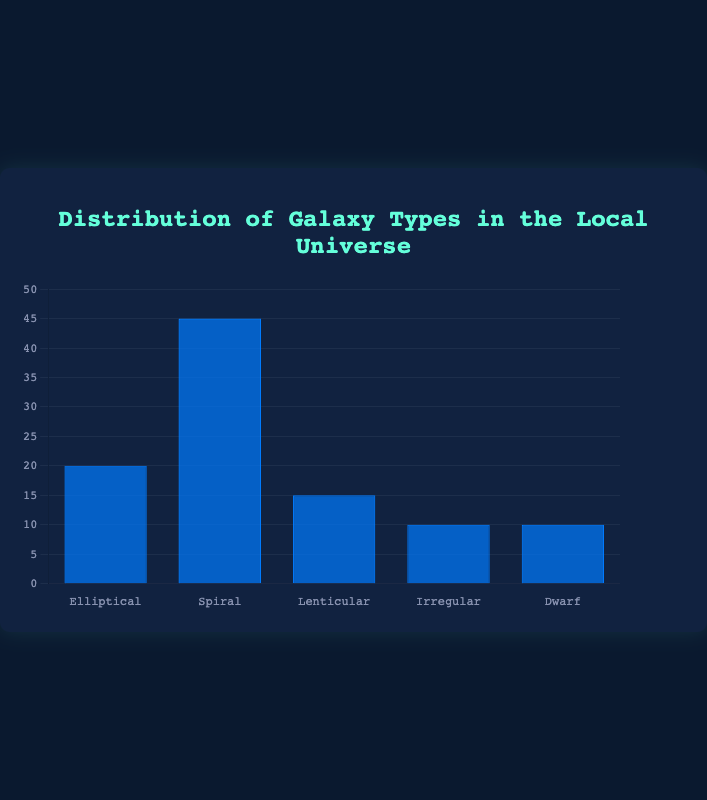What percentage of galaxies are Spiral Galaxies? From the bar chart, we see that the bar representing Spiral Galaxies reaches the 45% mark on the y-axis.
Answer: 45% Which galaxy type is the least common and what is its percentage? By observing the heights of the bars, we notice that Irregular and Dwarf Galaxies both have the shortest bars at the 10% mark.
Answer: Irregular and Dwarf Galaxies, 10% Calculate the total percentage of elliptical and lenticular galaxies. Sum the percentages of Elliptical Galaxies (20%) and Lenticular Galaxies (15%). 20% + 15% = 35%
Answer: 35% How does the percentage of Spiral Galaxies compare to the combined percentage of Irregular and Dwarf Galaxies? The percentage for Spiral Galaxies is 45%. The combined percentage for Irregular and Dwarf Galaxies is 10% + 10% = 20%. 45% is greater than 20%.
Answer: Spiral Galaxies > Combined Irregular and Dwarf Galaxies What is the difference in percentage between the most common and the least common galaxy types? The most common galaxy type is Spiral Galaxies at 45%. The least common galaxy types are Irregular and Dwarf Galaxies at 10%. The difference is 45% - 10% = 35%.
Answer: 35% What percentage of galaxies are neither Spiral nor Elliptical? Sum the percentages of Lenticular, Irregular, and Dwarf Galaxies. 15% + 10% + 10% = 35%.
Answer: 35% How many more percentage points do Spiral Galaxies have compared to Elliptical Galaxies? The percentage for Spiral Galaxies is 45% and for Elliptical Galaxies is 20%. The difference is 45% - 20% = 25%.
Answer: 25% Rank the galaxy types from most to least common based on the percentages. The bars most to least in height: Spiral Galaxies (45%), Elliptical Galaxies (20%), Lenticular Galaxies (15%), Irregular and Dwarf Galaxies (10%).
Answer: Spiral, Elliptical, Lenticular, Irregular, Dwarf Determine the average percentage of the five galaxy types. Sum of all percentages: 20% + 45% + 15% + 10% + 10% = 100%. Divide by the number of types: 100% / 5 = 20%.
Answer: 20% 